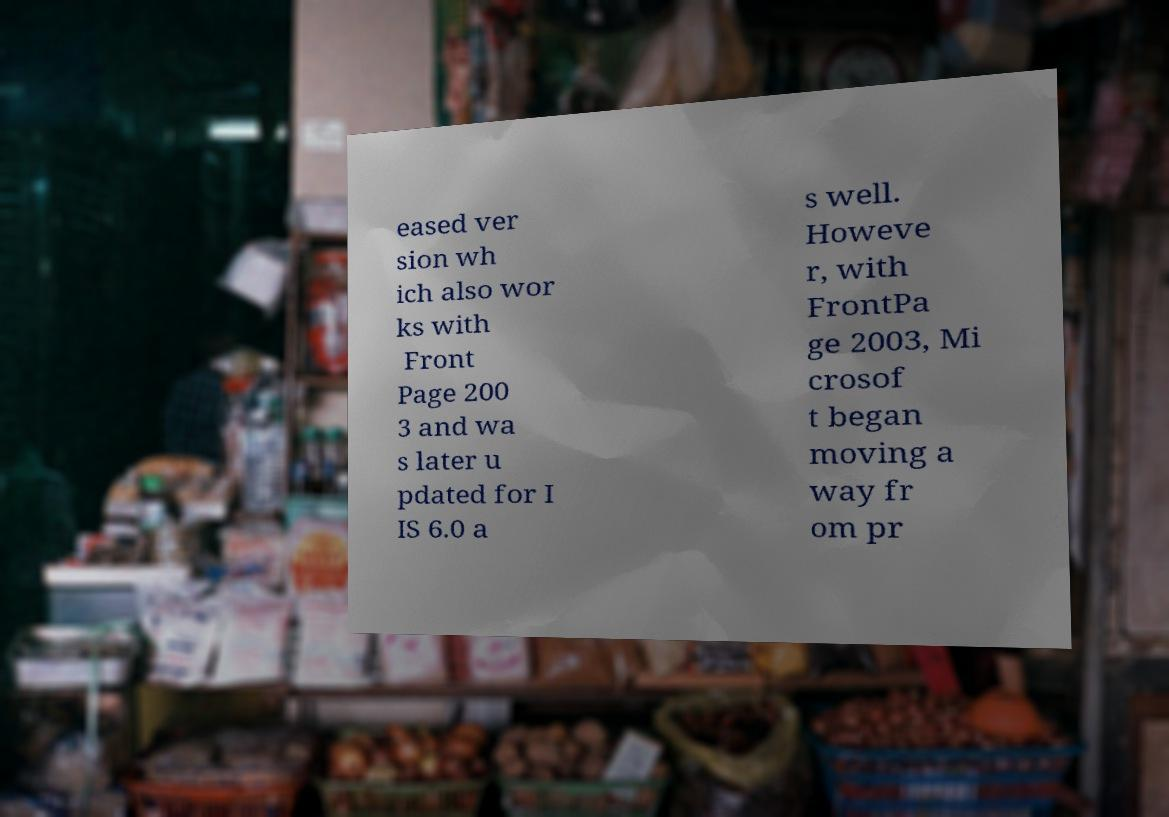There's text embedded in this image that I need extracted. Can you transcribe it verbatim? eased ver sion wh ich also wor ks with Front Page 200 3 and wa s later u pdated for I IS 6.0 a s well. Howeve r, with FrontPa ge 2003, Mi crosof t began moving a way fr om pr 